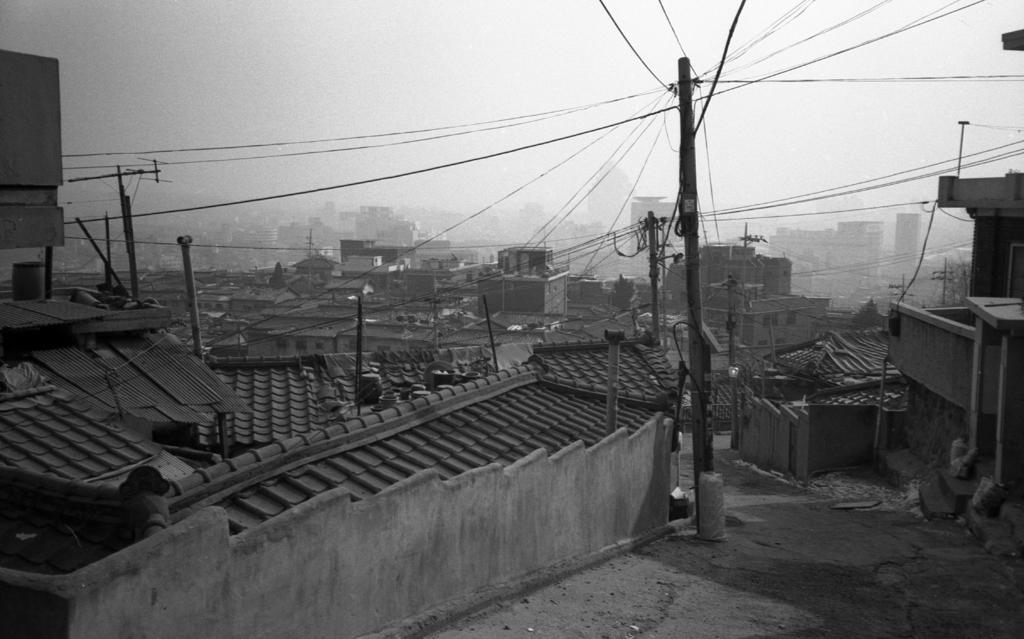What type of structures can be seen in the image? There are electric poles and houses in the image. What is visible at the top of the image? The sky is visible at the top of the image. What type of spark can be seen coming from the electric poles in the image? There is no spark visible coming from the electric poles in the image. Who is the representative present in the image? There is no representative present in the image. 